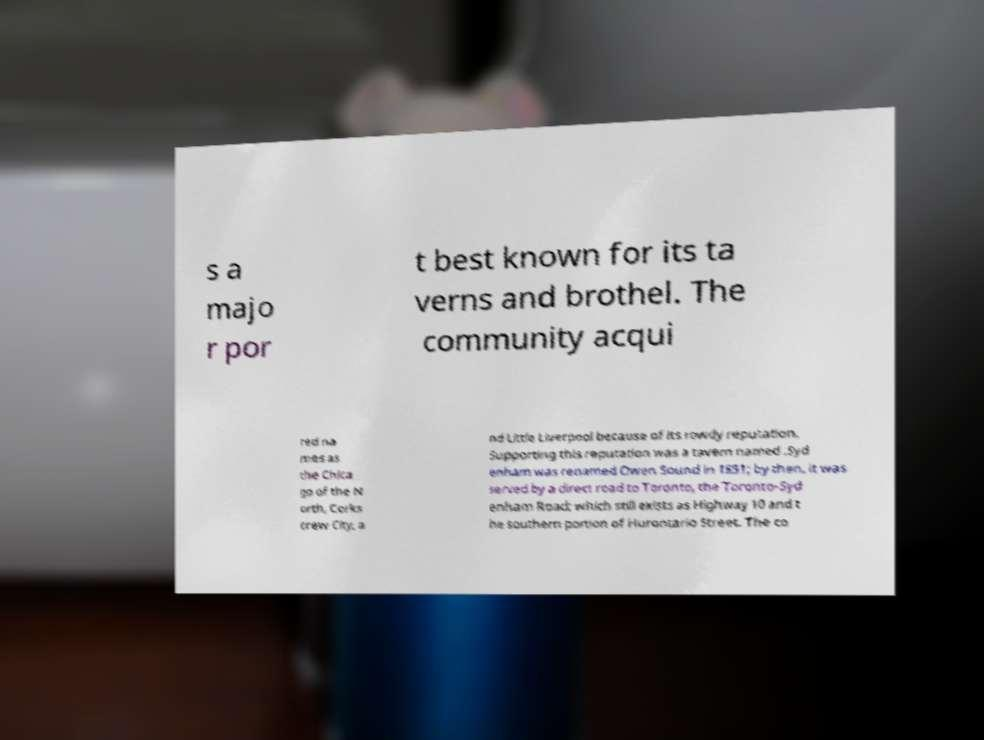There's text embedded in this image that I need extracted. Can you transcribe it verbatim? s a majo r por t best known for its ta verns and brothel. The community acqui red na mes as the Chica go of the N orth, Corks crew City, a nd Little Liverpool because of its rowdy reputation. Supporting this reputation was a tavern named .Syd enham was renamed Owen Sound in 1851; by then, it was served by a direct road to Toronto, the Toronto-Syd enham Road; which still exists as Highway 10 and t he southern portion of Hurontario Street. The co 